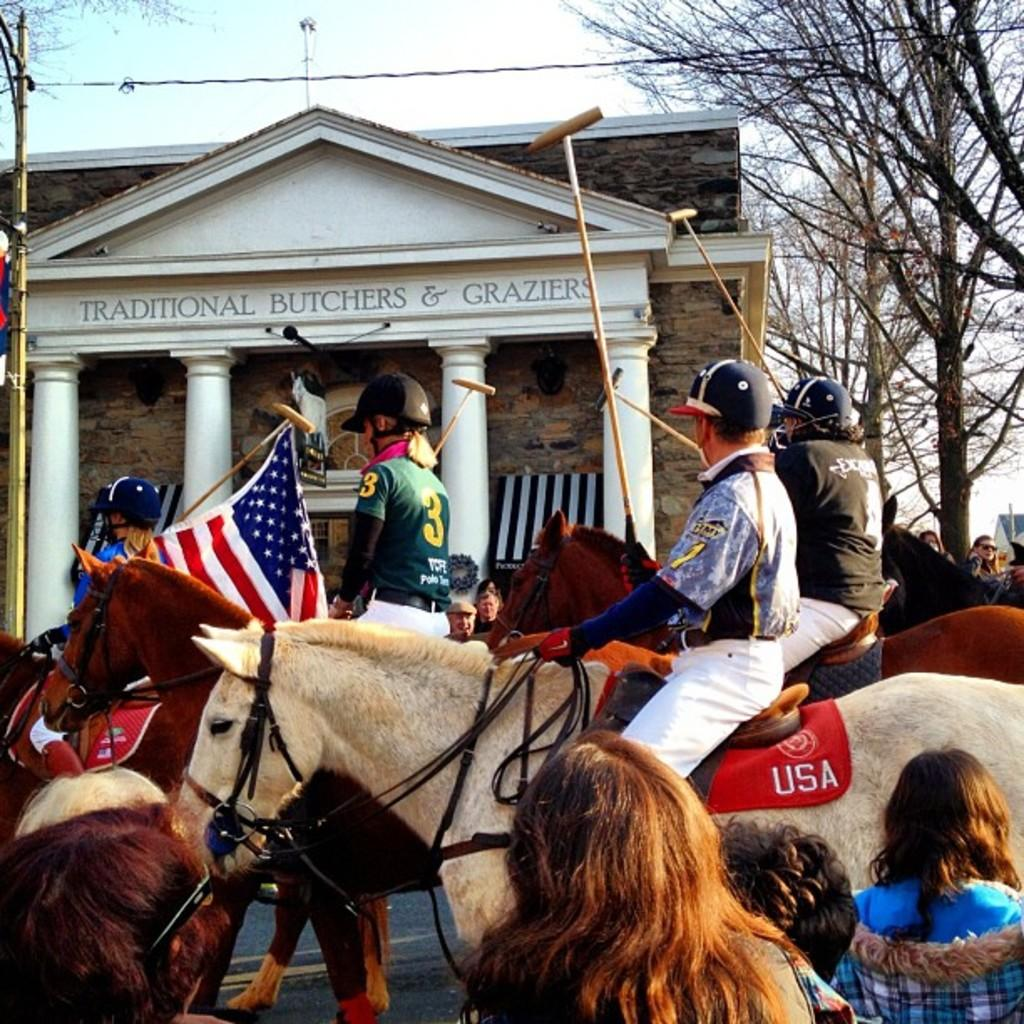How many people are in the image? There is a group of people in the image, but the exact number is not specified. What are some people doing with the horse in the image? Some people are sitting on the horse, and some are riding it. Where does the scene take place? The scene takes place in a street. What other objects or structures can be seen in the image? There is a flag, a building, a tree, and the sky is visible in the image. Are there any people standing near the horse? Yes, there is a group of people standing near the horse. What type of vegetable is being used as a unit of measurement for the stocking in the image? There is no vegetable, unit of measurement, or stocking present in the image. 